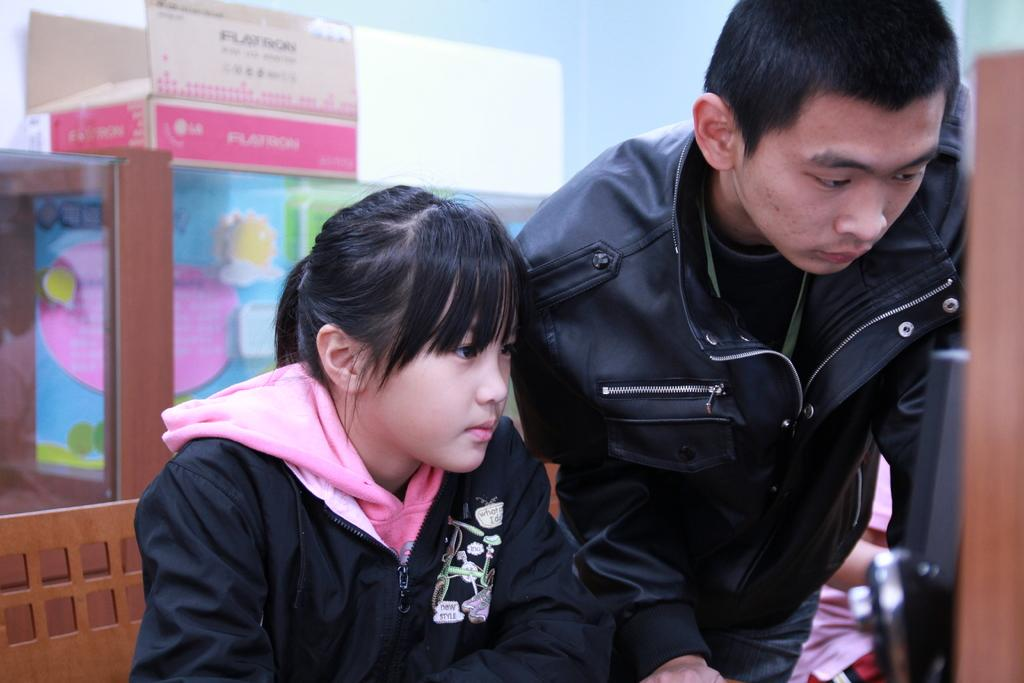Who can be seen in the foreground of the image? There is a man and a girl in the foreground of the image. What is located in the foreground of the image with the man and girl? There is a chair and other objects in the foreground of the image. What can be seen towards the left side of the image? There are boxes, a wall, and wooden objects towards the left side of the image. What is visible in the background of the image? There is a well in the background of the image. What type of pain is the man experiencing in the image? There is no indication of pain in the image. --- Facts: 1. There is a person in the image. 2. The person is wearing a hat. 3. The person is holding a book. 4. There is a table in the image. 5. The table has a vase with flowers on it. 6. There is a window in the background of the image. Absurd Topics: elephant, piano Conversation: Who or what can be seen in the image? There is a person in the image. What is the person wearing in the image? The person is wearing a hat. What is the person holding in the image? The person is holding a book. What can be seen on the table in the image? The table has a vase with flowers on it. What can be seen in the background of the image? There is a window in the background of the image. Reasoning: Let's think step by step in order to produce the conversation. We start by identifying the main subject in the image, which is the person. Then, we describe the person's attire and what they are holding. Next, we observe the objects and structures that are also visible, such as the table and its contents. Finally, we describe the background of the image, which includes the window. We ensure that each question can be answered definitively with the information given. Absurd Question/Answer: What type of elephant can be seen playing the piano in the image? There is no elephant or piano present in the image. 